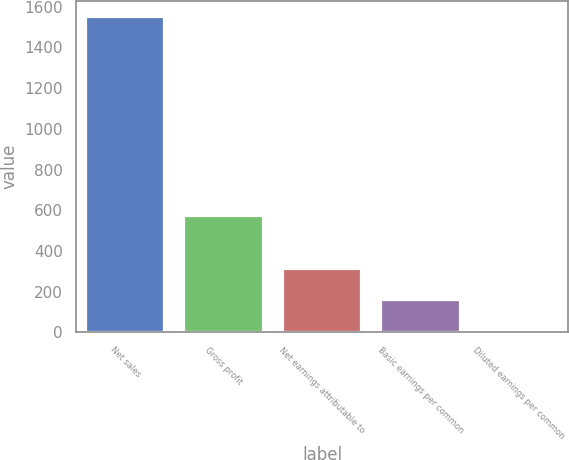Convert chart. <chart><loc_0><loc_0><loc_500><loc_500><bar_chart><fcel>Net sales<fcel>Gross profit<fcel>Net earnings attributable to<fcel>Basic earnings per common<fcel>Diluted earnings per common<nl><fcel>1551.8<fcel>571.2<fcel>311.63<fcel>156.61<fcel>1.59<nl></chart> 